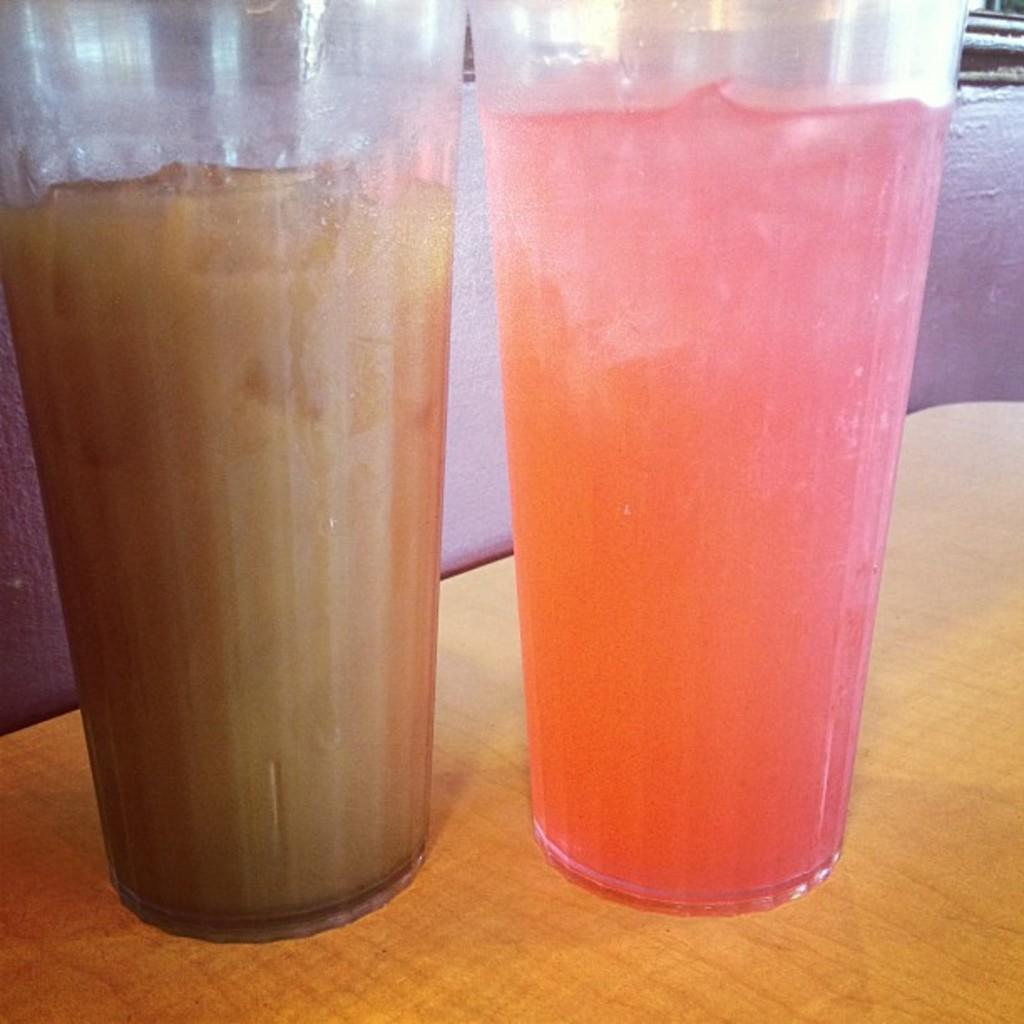What is inside the glasses that are visible in the image? There are beverages in the glasses that are visible in the image. Where are the glasses placed in the image? The glasses are placed on a table in the image. What can be seen in the background of the image? There is a wall in the background of the image. What type of animal is featured in the plot of the image? There is no animal or plot present in the image; it simply shows glasses containing beverages on a table with a wall in the background. 